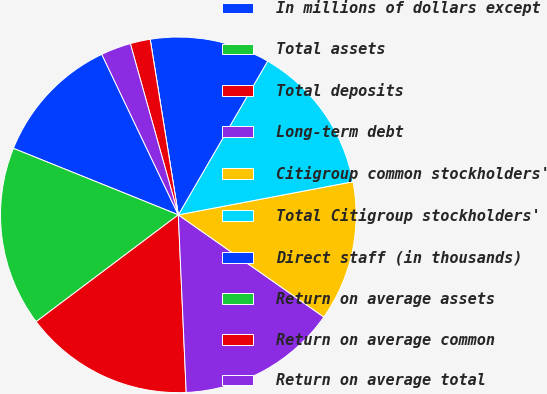Convert chart. <chart><loc_0><loc_0><loc_500><loc_500><pie_chart><fcel>In millions of dollars except<fcel>Total assets<fcel>Total deposits<fcel>Long-term debt<fcel>Citigroup common stockholders'<fcel>Total Citigroup stockholders'<fcel>Direct staff (in thousands)<fcel>Return on average assets<fcel>Return on average common<fcel>Return on average total<nl><fcel>11.82%<fcel>16.36%<fcel>15.45%<fcel>14.55%<fcel>12.73%<fcel>13.64%<fcel>10.91%<fcel>0.0%<fcel>1.82%<fcel>2.73%<nl></chart> 